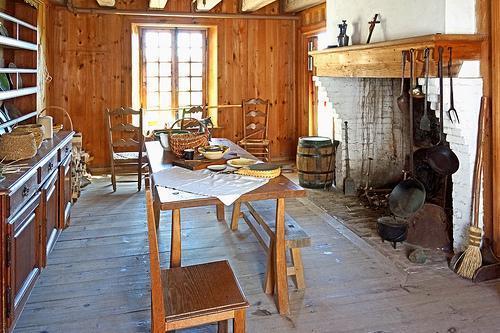How many chairs are in the picture?
Give a very brief answer. 3. 